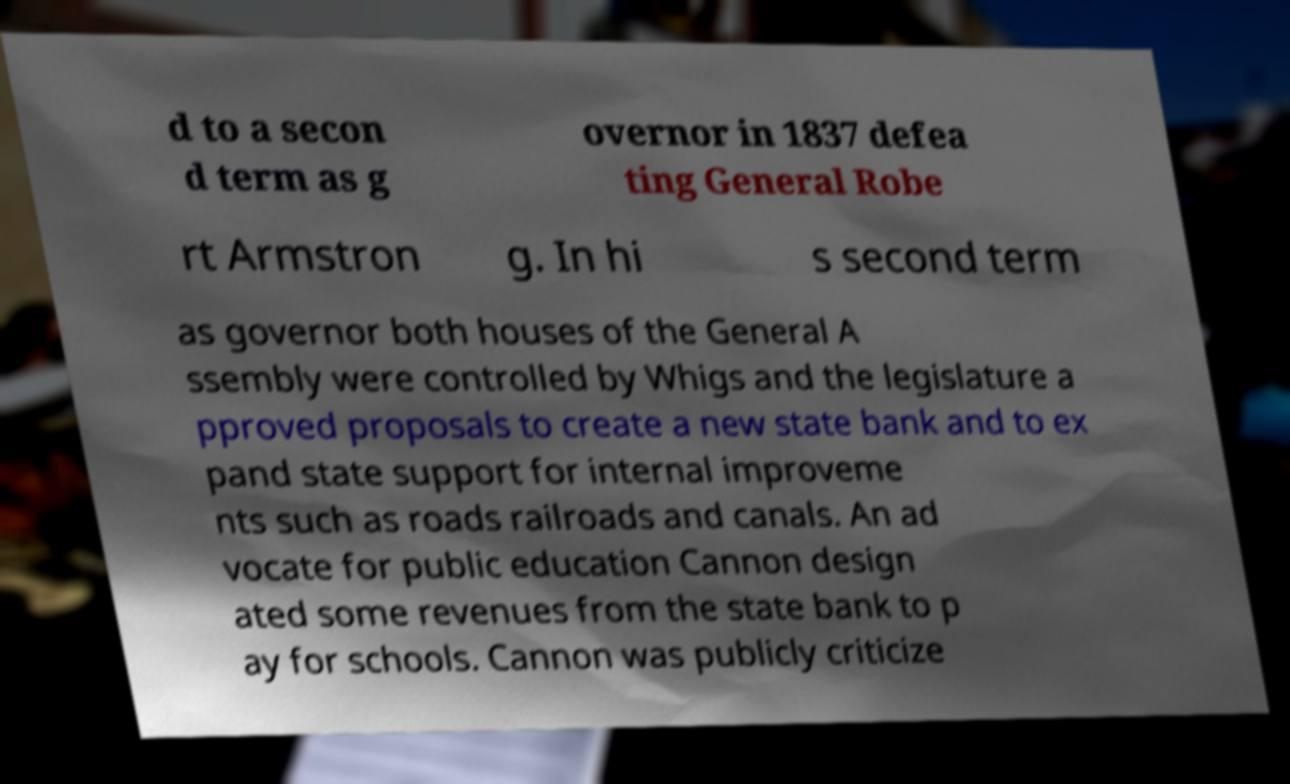I need the written content from this picture converted into text. Can you do that? d to a secon d term as g overnor in 1837 defea ting General Robe rt Armstron g. In hi s second term as governor both houses of the General A ssembly were controlled by Whigs and the legislature a pproved proposals to create a new state bank and to ex pand state support for internal improveme nts such as roads railroads and canals. An ad vocate for public education Cannon design ated some revenues from the state bank to p ay for schools. Cannon was publicly criticize 